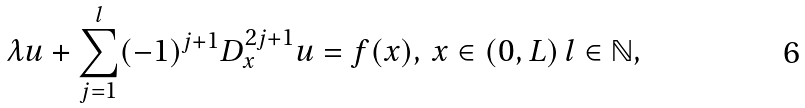<formula> <loc_0><loc_0><loc_500><loc_500>\lambda u + \sum _ { j = 1 } ^ { l } ( - 1 ) ^ { j + 1 } D _ { x } ^ { 2 j + 1 } u = f ( x ) , \, x \in ( 0 , L ) \, l \in \mathbb { N } ,</formula> 